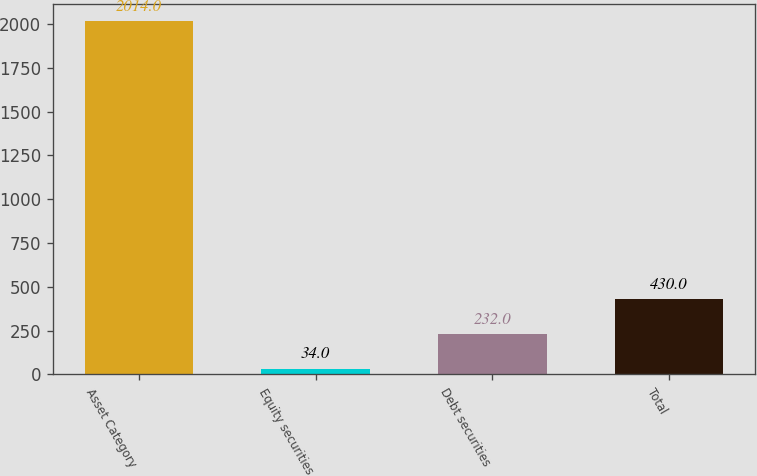<chart> <loc_0><loc_0><loc_500><loc_500><bar_chart><fcel>Asset Category<fcel>Equity securities<fcel>Debt securities<fcel>Total<nl><fcel>2014<fcel>34<fcel>232<fcel>430<nl></chart> 